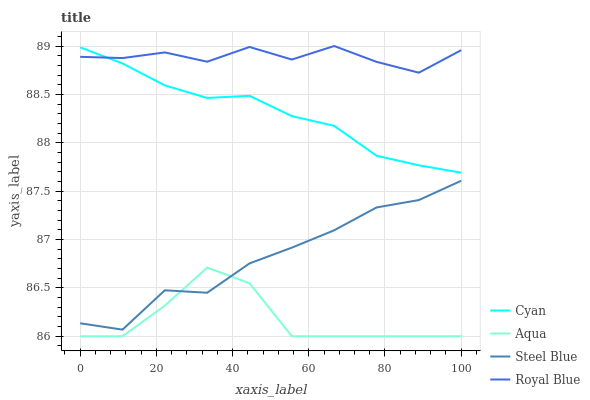Does Aqua have the minimum area under the curve?
Answer yes or no. Yes. Does Royal Blue have the maximum area under the curve?
Answer yes or no. Yes. Does Steel Blue have the minimum area under the curve?
Answer yes or no. No. Does Steel Blue have the maximum area under the curve?
Answer yes or no. No. Is Cyan the smoothest?
Answer yes or no. Yes. Is Aqua the roughest?
Answer yes or no. Yes. Is Steel Blue the smoothest?
Answer yes or no. No. Is Steel Blue the roughest?
Answer yes or no. No. Does Aqua have the lowest value?
Answer yes or no. Yes. Does Steel Blue have the lowest value?
Answer yes or no. No. Does Royal Blue have the highest value?
Answer yes or no. Yes. Does Steel Blue have the highest value?
Answer yes or no. No. Is Steel Blue less than Royal Blue?
Answer yes or no. Yes. Is Cyan greater than Aqua?
Answer yes or no. Yes. Does Royal Blue intersect Cyan?
Answer yes or no. Yes. Is Royal Blue less than Cyan?
Answer yes or no. No. Is Royal Blue greater than Cyan?
Answer yes or no. No. Does Steel Blue intersect Royal Blue?
Answer yes or no. No. 